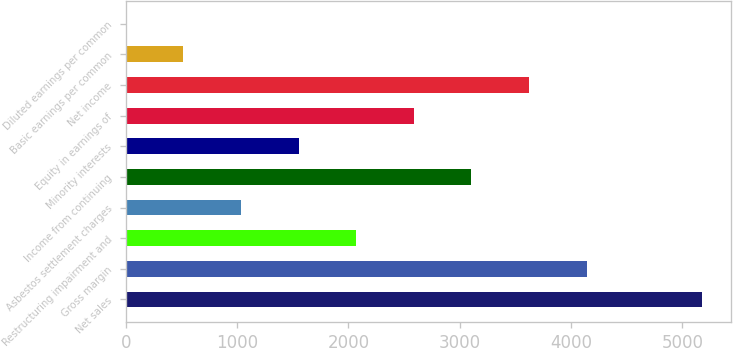Convert chart to OTSL. <chart><loc_0><loc_0><loc_500><loc_500><bar_chart><fcel>Net sales<fcel>Gross margin<fcel>Restructuring impairment and<fcel>Asbestos settlement charges<fcel>Income from continuing<fcel>Minority interests<fcel>Equity in earnings of<fcel>Net income<fcel>Basic earnings per common<fcel>Diluted earnings per common<nl><fcel>5174<fcel>4139.4<fcel>2070.28<fcel>1035.72<fcel>3104.84<fcel>1553<fcel>2587.56<fcel>3622.12<fcel>518.44<fcel>1.16<nl></chart> 